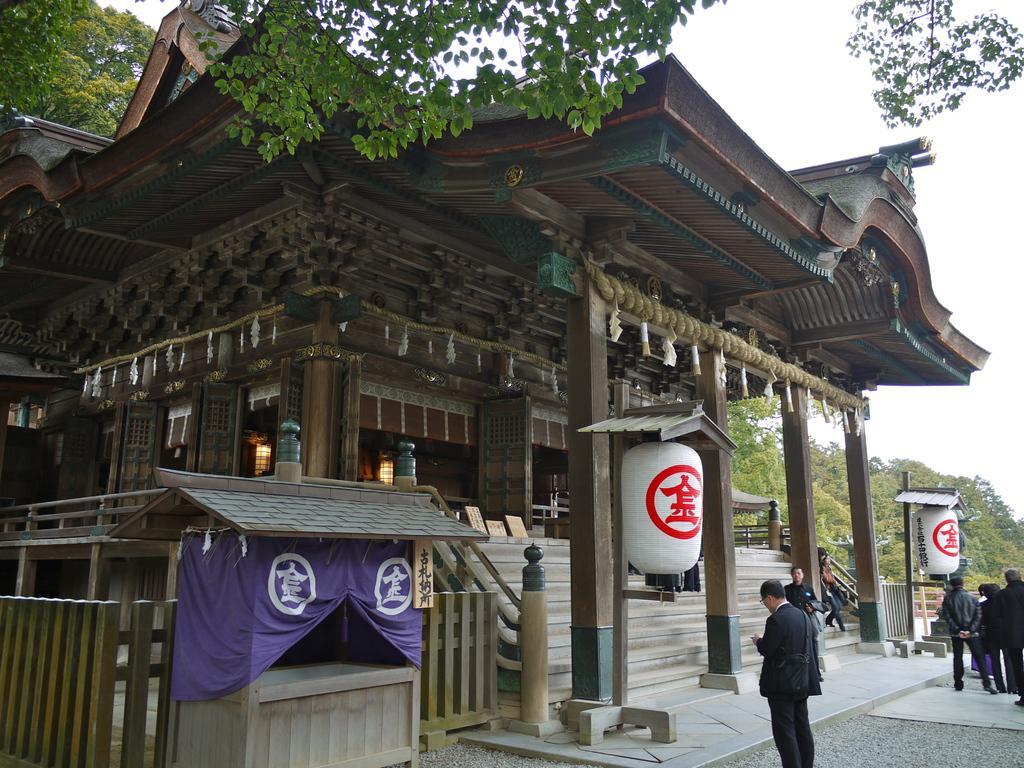Please provide a concise description of this image. This image is taken outdoors. At the top of the image there is the sky. In the background there are many trees with leaves, stems and branches. At the bottom of the image there is a floor. In the middle of the image there is Chinese architecture with walls, pillars, doors, windows and a roof. There are a few carvings on the walls. There are a few stairs. There is a railing. There is a fence and there is a cabin. There are a few wooden sticks. There are two lamps. On the right side of the image a few people are standing on the floor and a few are standing on the stairs. 